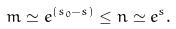Convert formula to latex. <formula><loc_0><loc_0><loc_500><loc_500>m \simeq e ^ { ( s _ { 0 } - s ) } \leq n \simeq e ^ { s } .</formula> 